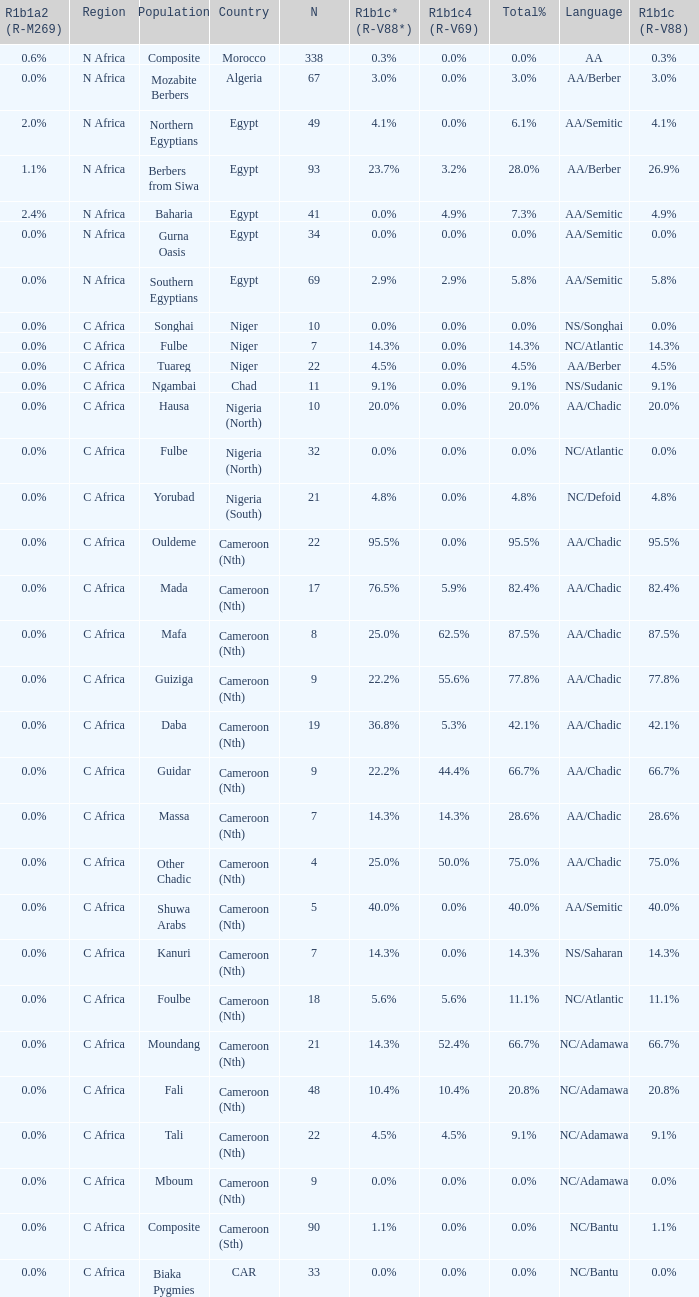What percentage is recorded in column r1b1c (r-v88) for the 4.5%. 